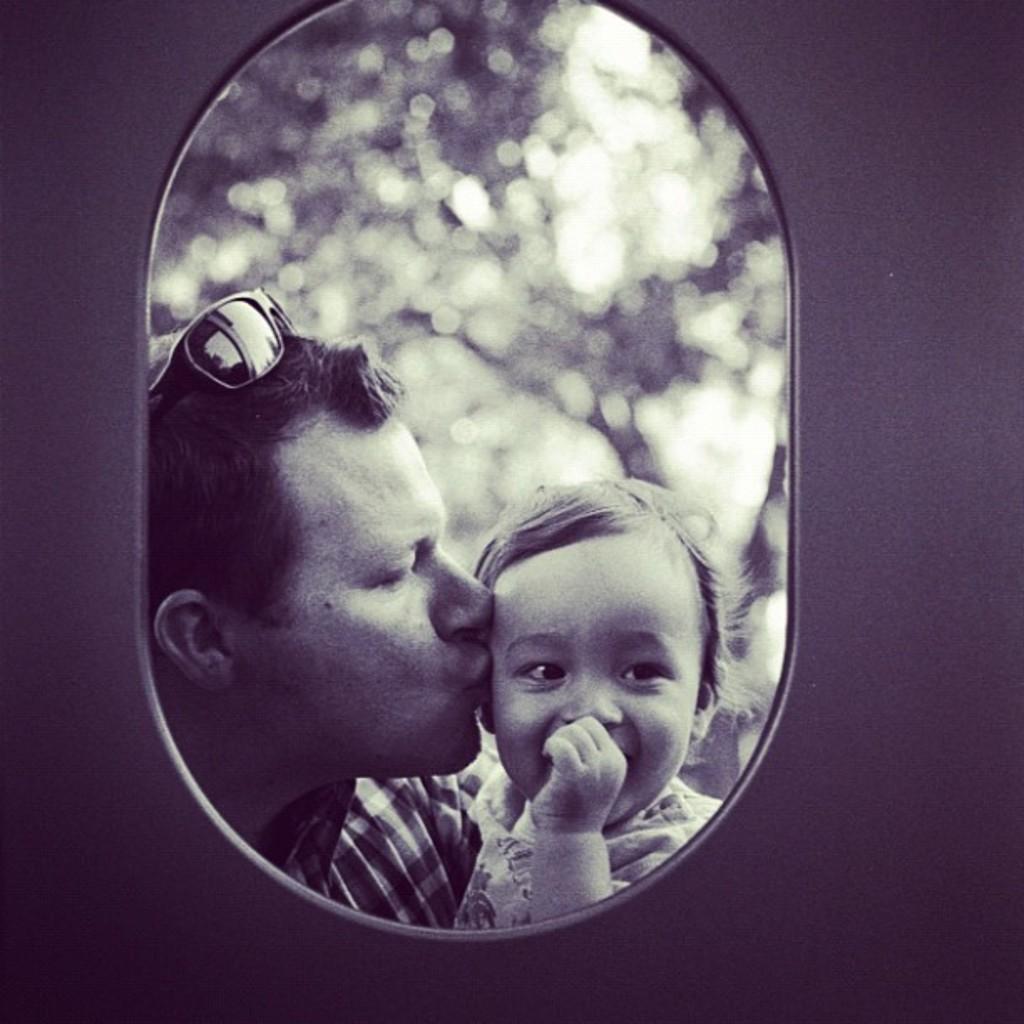Can you describe this image briefly? In the image we can see a man and a child wearing clothes. These are the goggles and this is a window. The background is blurred. 